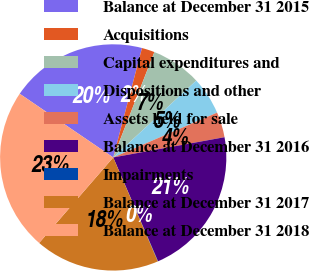Convert chart to OTSL. <chart><loc_0><loc_0><loc_500><loc_500><pie_chart><fcel>Balance at December 31 2015<fcel>Acquisitions<fcel>Capital expenditures and<fcel>Dispositions and other<fcel>Assets held for sale<fcel>Balance at December 31 2016<fcel>Impairments<fcel>Balance at December 31 2017<fcel>Balance at December 31 2018<nl><fcel>19.58%<fcel>1.83%<fcel>7.19%<fcel>5.4%<fcel>3.62%<fcel>21.37%<fcel>0.05%<fcel>17.8%<fcel>23.15%<nl></chart> 